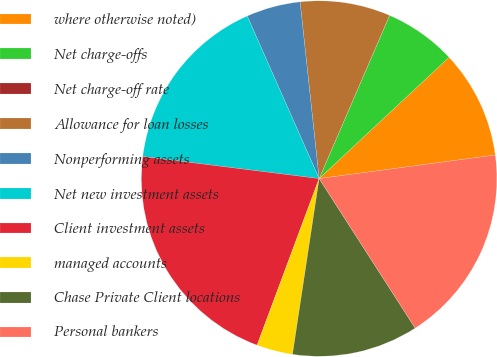<chart> <loc_0><loc_0><loc_500><loc_500><pie_chart><fcel>where otherwise noted)<fcel>Net charge-offs<fcel>Net charge-off rate<fcel>Allowance for loan losses<fcel>Nonperforming assets<fcel>Net new investment assets<fcel>Client investment assets<fcel>managed accounts<fcel>Chase Private Client locations<fcel>Personal bankers<nl><fcel>9.84%<fcel>6.56%<fcel>0.0%<fcel>8.2%<fcel>4.92%<fcel>16.39%<fcel>21.31%<fcel>3.28%<fcel>11.48%<fcel>18.03%<nl></chart> 